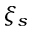<formula> <loc_0><loc_0><loc_500><loc_500>\xi _ { s }</formula> 